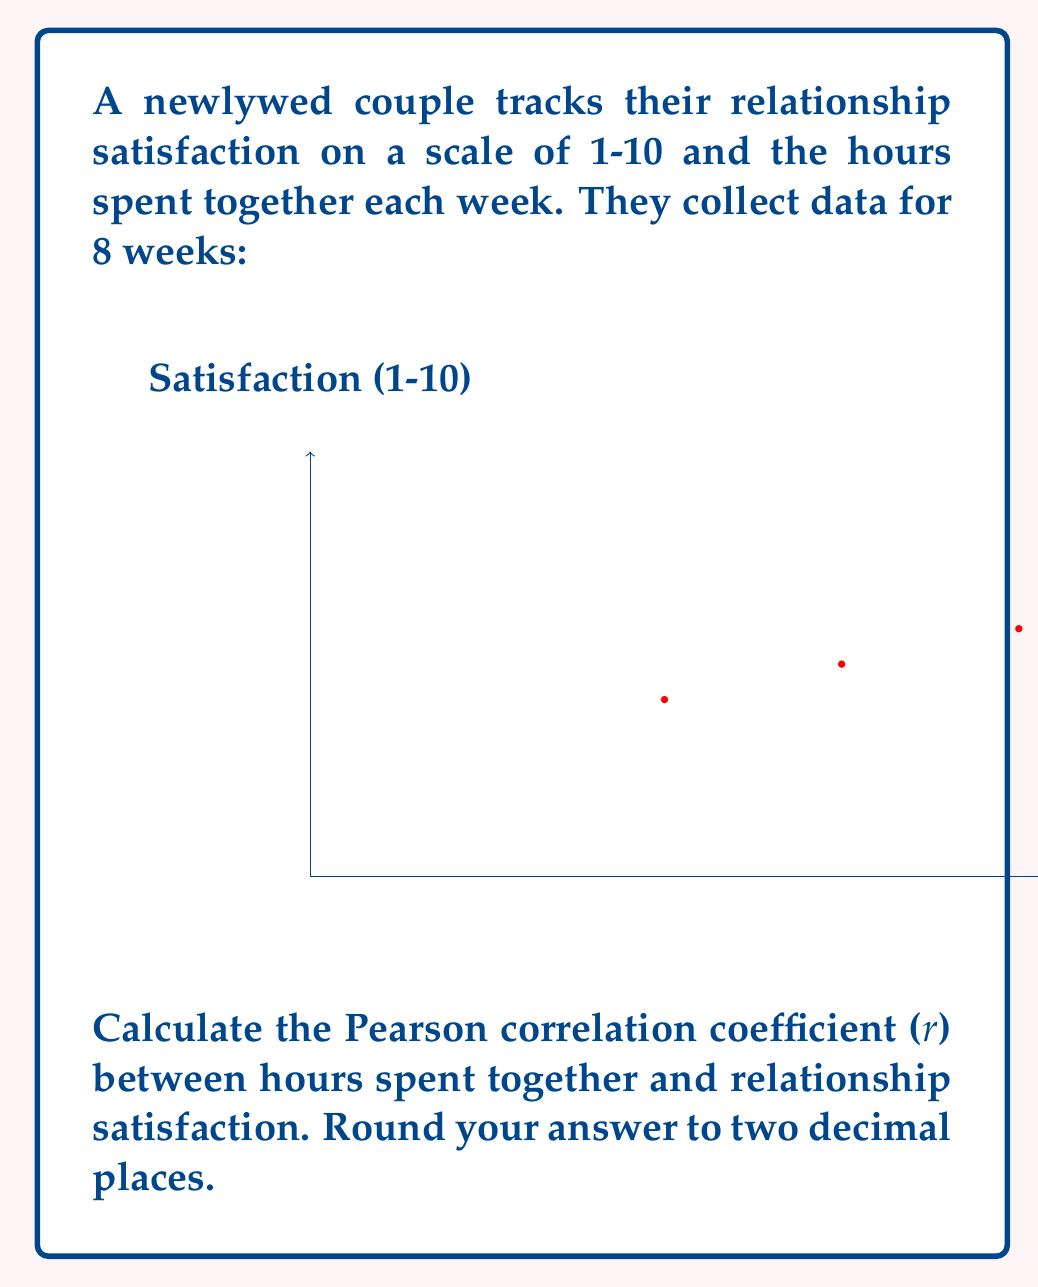Solve this math problem. To calculate the Pearson correlation coefficient (r), we'll use the formula:

$$ r = \frac{\sum_{i=1}^{n} (x_i - \bar{x})(y_i - \bar{y})}{\sqrt{\sum_{i=1}^{n} (x_i - \bar{x})^2 \sum_{i=1}^{n} (y_i - \bar{y})^2}} $$

Where:
$x_i$ = hours spent together
$y_i$ = satisfaction rating
$\bar{x}$ = mean of hours spent together
$\bar{y}$ = mean of satisfaction ratings
$n$ = number of data points (8)

Step 1: Calculate means
$\bar{x} = \frac{10+15+20+25+30+35+40+45}{8} = 27.5$
$\bar{y} = \frac{5+6+7+8+8+9+9+10}{8} = 7.75$

Step 2: Calculate $(x_i - \bar{x})$, $(y_i - \bar{y})$, $(x_i - \bar{x})^2$, $(y_i - \bar{y})^2$, and $(x_i - \bar{x})(y_i - \bar{y})$

Step 3: Sum the calculated values
$\sum (x_i - \bar{x})(y_i - \bar{y}) = 157.5$
$\sum (x_i - \bar{x})^2 = 1050$
$\sum (y_i - \bar{y})^2 = 16.75$

Step 4: Apply the formula
$$ r = \frac{157.5}{\sqrt{1050 * 16.75}} = \frac{157.5}{\sqrt{17587.5}} = \frac{157.5}{132.62} = 0.9877 $$

Step 5: Round to two decimal places
$r \approx 0.99$
Answer: 0.99 